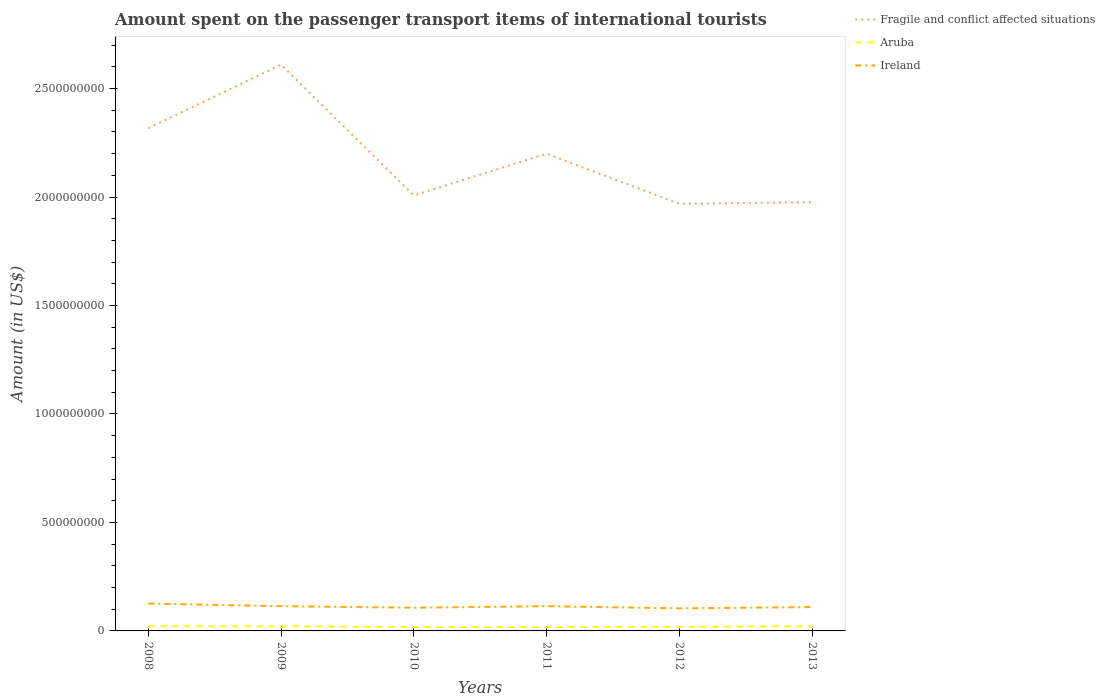How many different coloured lines are there?
Offer a very short reply. 3. Is the number of lines equal to the number of legend labels?
Offer a terse response. Yes. Across all years, what is the maximum amount spent on the passenger transport items of international tourists in Aruba?
Give a very brief answer. 1.80e+07. In which year was the amount spent on the passenger transport items of international tourists in Aruba maximum?
Keep it short and to the point. 2010. What is the total amount spent on the passenger transport items of international tourists in Ireland in the graph?
Provide a short and direct response. 1.90e+07. What is the difference between the highest and the second highest amount spent on the passenger transport items of international tourists in Aruba?
Offer a very short reply. 4.00e+06. Is the amount spent on the passenger transport items of international tourists in Fragile and conflict affected situations strictly greater than the amount spent on the passenger transport items of international tourists in Ireland over the years?
Give a very brief answer. No. How many lines are there?
Your answer should be compact. 3. How many years are there in the graph?
Ensure brevity in your answer.  6. What is the title of the graph?
Your response must be concise. Amount spent on the passenger transport items of international tourists. Does "Slovak Republic" appear as one of the legend labels in the graph?
Keep it short and to the point. No. What is the label or title of the Y-axis?
Offer a terse response. Amount (in US$). What is the Amount (in US$) in Fragile and conflict affected situations in 2008?
Provide a short and direct response. 2.32e+09. What is the Amount (in US$) of Aruba in 2008?
Offer a very short reply. 2.20e+07. What is the Amount (in US$) of Ireland in 2008?
Give a very brief answer. 1.26e+08. What is the Amount (in US$) in Fragile and conflict affected situations in 2009?
Make the answer very short. 2.61e+09. What is the Amount (in US$) in Aruba in 2009?
Keep it short and to the point. 2.10e+07. What is the Amount (in US$) in Ireland in 2009?
Your response must be concise. 1.14e+08. What is the Amount (in US$) in Fragile and conflict affected situations in 2010?
Ensure brevity in your answer.  2.01e+09. What is the Amount (in US$) of Aruba in 2010?
Your response must be concise. 1.80e+07. What is the Amount (in US$) in Ireland in 2010?
Offer a terse response. 1.07e+08. What is the Amount (in US$) of Fragile and conflict affected situations in 2011?
Your answer should be very brief. 2.20e+09. What is the Amount (in US$) in Aruba in 2011?
Provide a short and direct response. 1.80e+07. What is the Amount (in US$) of Ireland in 2011?
Provide a short and direct response. 1.14e+08. What is the Amount (in US$) in Fragile and conflict affected situations in 2012?
Offer a very short reply. 1.97e+09. What is the Amount (in US$) of Aruba in 2012?
Make the answer very short. 1.90e+07. What is the Amount (in US$) of Ireland in 2012?
Offer a terse response. 1.04e+08. What is the Amount (in US$) of Fragile and conflict affected situations in 2013?
Ensure brevity in your answer.  1.98e+09. What is the Amount (in US$) in Aruba in 2013?
Provide a short and direct response. 2.10e+07. What is the Amount (in US$) of Ireland in 2013?
Keep it short and to the point. 1.10e+08. Across all years, what is the maximum Amount (in US$) of Fragile and conflict affected situations?
Offer a very short reply. 2.61e+09. Across all years, what is the maximum Amount (in US$) of Aruba?
Ensure brevity in your answer.  2.20e+07. Across all years, what is the maximum Amount (in US$) of Ireland?
Offer a very short reply. 1.26e+08. Across all years, what is the minimum Amount (in US$) of Fragile and conflict affected situations?
Your answer should be compact. 1.97e+09. Across all years, what is the minimum Amount (in US$) of Aruba?
Provide a short and direct response. 1.80e+07. Across all years, what is the minimum Amount (in US$) of Ireland?
Make the answer very short. 1.04e+08. What is the total Amount (in US$) in Fragile and conflict affected situations in the graph?
Your response must be concise. 1.31e+1. What is the total Amount (in US$) of Aruba in the graph?
Give a very brief answer. 1.19e+08. What is the total Amount (in US$) of Ireland in the graph?
Provide a short and direct response. 6.75e+08. What is the difference between the Amount (in US$) of Fragile and conflict affected situations in 2008 and that in 2009?
Your answer should be compact. -2.92e+08. What is the difference between the Amount (in US$) in Aruba in 2008 and that in 2009?
Provide a succinct answer. 1.00e+06. What is the difference between the Amount (in US$) in Ireland in 2008 and that in 2009?
Offer a terse response. 1.20e+07. What is the difference between the Amount (in US$) in Fragile and conflict affected situations in 2008 and that in 2010?
Provide a short and direct response. 3.10e+08. What is the difference between the Amount (in US$) in Aruba in 2008 and that in 2010?
Provide a short and direct response. 4.00e+06. What is the difference between the Amount (in US$) in Ireland in 2008 and that in 2010?
Offer a terse response. 1.90e+07. What is the difference between the Amount (in US$) of Fragile and conflict affected situations in 2008 and that in 2011?
Ensure brevity in your answer.  1.18e+08. What is the difference between the Amount (in US$) of Aruba in 2008 and that in 2011?
Offer a very short reply. 4.00e+06. What is the difference between the Amount (in US$) of Fragile and conflict affected situations in 2008 and that in 2012?
Your answer should be very brief. 3.49e+08. What is the difference between the Amount (in US$) of Ireland in 2008 and that in 2012?
Offer a terse response. 2.20e+07. What is the difference between the Amount (in US$) of Fragile and conflict affected situations in 2008 and that in 2013?
Give a very brief answer. 3.41e+08. What is the difference between the Amount (in US$) in Aruba in 2008 and that in 2013?
Your response must be concise. 1.00e+06. What is the difference between the Amount (in US$) of Ireland in 2008 and that in 2013?
Offer a terse response. 1.60e+07. What is the difference between the Amount (in US$) of Fragile and conflict affected situations in 2009 and that in 2010?
Offer a very short reply. 6.03e+08. What is the difference between the Amount (in US$) in Ireland in 2009 and that in 2010?
Offer a terse response. 7.00e+06. What is the difference between the Amount (in US$) of Fragile and conflict affected situations in 2009 and that in 2011?
Ensure brevity in your answer.  4.10e+08. What is the difference between the Amount (in US$) in Aruba in 2009 and that in 2011?
Offer a terse response. 3.00e+06. What is the difference between the Amount (in US$) in Fragile and conflict affected situations in 2009 and that in 2012?
Your response must be concise. 6.41e+08. What is the difference between the Amount (in US$) of Fragile and conflict affected situations in 2009 and that in 2013?
Give a very brief answer. 6.34e+08. What is the difference between the Amount (in US$) of Fragile and conflict affected situations in 2010 and that in 2011?
Provide a short and direct response. -1.92e+08. What is the difference between the Amount (in US$) in Aruba in 2010 and that in 2011?
Your answer should be very brief. 0. What is the difference between the Amount (in US$) in Ireland in 2010 and that in 2011?
Give a very brief answer. -7.00e+06. What is the difference between the Amount (in US$) in Fragile and conflict affected situations in 2010 and that in 2012?
Give a very brief answer. 3.86e+07. What is the difference between the Amount (in US$) of Aruba in 2010 and that in 2012?
Provide a short and direct response. -1.00e+06. What is the difference between the Amount (in US$) in Ireland in 2010 and that in 2012?
Keep it short and to the point. 3.00e+06. What is the difference between the Amount (in US$) of Fragile and conflict affected situations in 2010 and that in 2013?
Your answer should be very brief. 3.11e+07. What is the difference between the Amount (in US$) in Fragile and conflict affected situations in 2011 and that in 2012?
Give a very brief answer. 2.31e+08. What is the difference between the Amount (in US$) of Ireland in 2011 and that in 2012?
Keep it short and to the point. 1.00e+07. What is the difference between the Amount (in US$) of Fragile and conflict affected situations in 2011 and that in 2013?
Offer a terse response. 2.23e+08. What is the difference between the Amount (in US$) of Fragile and conflict affected situations in 2012 and that in 2013?
Ensure brevity in your answer.  -7.56e+06. What is the difference between the Amount (in US$) of Ireland in 2012 and that in 2013?
Offer a terse response. -6.00e+06. What is the difference between the Amount (in US$) of Fragile and conflict affected situations in 2008 and the Amount (in US$) of Aruba in 2009?
Make the answer very short. 2.30e+09. What is the difference between the Amount (in US$) in Fragile and conflict affected situations in 2008 and the Amount (in US$) in Ireland in 2009?
Give a very brief answer. 2.20e+09. What is the difference between the Amount (in US$) in Aruba in 2008 and the Amount (in US$) in Ireland in 2009?
Offer a terse response. -9.20e+07. What is the difference between the Amount (in US$) of Fragile and conflict affected situations in 2008 and the Amount (in US$) of Aruba in 2010?
Offer a terse response. 2.30e+09. What is the difference between the Amount (in US$) of Fragile and conflict affected situations in 2008 and the Amount (in US$) of Ireland in 2010?
Make the answer very short. 2.21e+09. What is the difference between the Amount (in US$) of Aruba in 2008 and the Amount (in US$) of Ireland in 2010?
Make the answer very short. -8.50e+07. What is the difference between the Amount (in US$) in Fragile and conflict affected situations in 2008 and the Amount (in US$) in Aruba in 2011?
Your answer should be very brief. 2.30e+09. What is the difference between the Amount (in US$) of Fragile and conflict affected situations in 2008 and the Amount (in US$) of Ireland in 2011?
Your response must be concise. 2.20e+09. What is the difference between the Amount (in US$) of Aruba in 2008 and the Amount (in US$) of Ireland in 2011?
Provide a short and direct response. -9.20e+07. What is the difference between the Amount (in US$) in Fragile and conflict affected situations in 2008 and the Amount (in US$) in Aruba in 2012?
Make the answer very short. 2.30e+09. What is the difference between the Amount (in US$) of Fragile and conflict affected situations in 2008 and the Amount (in US$) of Ireland in 2012?
Make the answer very short. 2.21e+09. What is the difference between the Amount (in US$) in Aruba in 2008 and the Amount (in US$) in Ireland in 2012?
Your response must be concise. -8.20e+07. What is the difference between the Amount (in US$) of Fragile and conflict affected situations in 2008 and the Amount (in US$) of Aruba in 2013?
Make the answer very short. 2.30e+09. What is the difference between the Amount (in US$) in Fragile and conflict affected situations in 2008 and the Amount (in US$) in Ireland in 2013?
Ensure brevity in your answer.  2.21e+09. What is the difference between the Amount (in US$) in Aruba in 2008 and the Amount (in US$) in Ireland in 2013?
Make the answer very short. -8.80e+07. What is the difference between the Amount (in US$) in Fragile and conflict affected situations in 2009 and the Amount (in US$) in Aruba in 2010?
Give a very brief answer. 2.59e+09. What is the difference between the Amount (in US$) of Fragile and conflict affected situations in 2009 and the Amount (in US$) of Ireland in 2010?
Offer a terse response. 2.50e+09. What is the difference between the Amount (in US$) of Aruba in 2009 and the Amount (in US$) of Ireland in 2010?
Your answer should be compact. -8.60e+07. What is the difference between the Amount (in US$) in Fragile and conflict affected situations in 2009 and the Amount (in US$) in Aruba in 2011?
Give a very brief answer. 2.59e+09. What is the difference between the Amount (in US$) of Fragile and conflict affected situations in 2009 and the Amount (in US$) of Ireland in 2011?
Ensure brevity in your answer.  2.50e+09. What is the difference between the Amount (in US$) in Aruba in 2009 and the Amount (in US$) in Ireland in 2011?
Offer a very short reply. -9.30e+07. What is the difference between the Amount (in US$) of Fragile and conflict affected situations in 2009 and the Amount (in US$) of Aruba in 2012?
Your answer should be very brief. 2.59e+09. What is the difference between the Amount (in US$) of Fragile and conflict affected situations in 2009 and the Amount (in US$) of Ireland in 2012?
Make the answer very short. 2.51e+09. What is the difference between the Amount (in US$) of Aruba in 2009 and the Amount (in US$) of Ireland in 2012?
Offer a very short reply. -8.30e+07. What is the difference between the Amount (in US$) in Fragile and conflict affected situations in 2009 and the Amount (in US$) in Aruba in 2013?
Provide a succinct answer. 2.59e+09. What is the difference between the Amount (in US$) in Fragile and conflict affected situations in 2009 and the Amount (in US$) in Ireland in 2013?
Your answer should be very brief. 2.50e+09. What is the difference between the Amount (in US$) of Aruba in 2009 and the Amount (in US$) of Ireland in 2013?
Your response must be concise. -8.90e+07. What is the difference between the Amount (in US$) of Fragile and conflict affected situations in 2010 and the Amount (in US$) of Aruba in 2011?
Ensure brevity in your answer.  1.99e+09. What is the difference between the Amount (in US$) in Fragile and conflict affected situations in 2010 and the Amount (in US$) in Ireland in 2011?
Provide a short and direct response. 1.89e+09. What is the difference between the Amount (in US$) of Aruba in 2010 and the Amount (in US$) of Ireland in 2011?
Your response must be concise. -9.60e+07. What is the difference between the Amount (in US$) in Fragile and conflict affected situations in 2010 and the Amount (in US$) in Aruba in 2012?
Your answer should be compact. 1.99e+09. What is the difference between the Amount (in US$) of Fragile and conflict affected situations in 2010 and the Amount (in US$) of Ireland in 2012?
Make the answer very short. 1.90e+09. What is the difference between the Amount (in US$) in Aruba in 2010 and the Amount (in US$) in Ireland in 2012?
Your answer should be compact. -8.60e+07. What is the difference between the Amount (in US$) of Fragile and conflict affected situations in 2010 and the Amount (in US$) of Aruba in 2013?
Your response must be concise. 1.99e+09. What is the difference between the Amount (in US$) of Fragile and conflict affected situations in 2010 and the Amount (in US$) of Ireland in 2013?
Keep it short and to the point. 1.90e+09. What is the difference between the Amount (in US$) in Aruba in 2010 and the Amount (in US$) in Ireland in 2013?
Offer a very short reply. -9.20e+07. What is the difference between the Amount (in US$) in Fragile and conflict affected situations in 2011 and the Amount (in US$) in Aruba in 2012?
Provide a succinct answer. 2.18e+09. What is the difference between the Amount (in US$) of Fragile and conflict affected situations in 2011 and the Amount (in US$) of Ireland in 2012?
Your answer should be very brief. 2.10e+09. What is the difference between the Amount (in US$) of Aruba in 2011 and the Amount (in US$) of Ireland in 2012?
Offer a terse response. -8.60e+07. What is the difference between the Amount (in US$) of Fragile and conflict affected situations in 2011 and the Amount (in US$) of Aruba in 2013?
Ensure brevity in your answer.  2.18e+09. What is the difference between the Amount (in US$) of Fragile and conflict affected situations in 2011 and the Amount (in US$) of Ireland in 2013?
Ensure brevity in your answer.  2.09e+09. What is the difference between the Amount (in US$) in Aruba in 2011 and the Amount (in US$) in Ireland in 2013?
Keep it short and to the point. -9.20e+07. What is the difference between the Amount (in US$) of Fragile and conflict affected situations in 2012 and the Amount (in US$) of Aruba in 2013?
Make the answer very short. 1.95e+09. What is the difference between the Amount (in US$) of Fragile and conflict affected situations in 2012 and the Amount (in US$) of Ireland in 2013?
Your response must be concise. 1.86e+09. What is the difference between the Amount (in US$) of Aruba in 2012 and the Amount (in US$) of Ireland in 2013?
Offer a very short reply. -9.10e+07. What is the average Amount (in US$) of Fragile and conflict affected situations per year?
Keep it short and to the point. 2.18e+09. What is the average Amount (in US$) in Aruba per year?
Your answer should be compact. 1.98e+07. What is the average Amount (in US$) of Ireland per year?
Your response must be concise. 1.12e+08. In the year 2008, what is the difference between the Amount (in US$) of Fragile and conflict affected situations and Amount (in US$) of Aruba?
Keep it short and to the point. 2.30e+09. In the year 2008, what is the difference between the Amount (in US$) in Fragile and conflict affected situations and Amount (in US$) in Ireland?
Offer a terse response. 2.19e+09. In the year 2008, what is the difference between the Amount (in US$) of Aruba and Amount (in US$) of Ireland?
Your response must be concise. -1.04e+08. In the year 2009, what is the difference between the Amount (in US$) of Fragile and conflict affected situations and Amount (in US$) of Aruba?
Your answer should be compact. 2.59e+09. In the year 2009, what is the difference between the Amount (in US$) of Fragile and conflict affected situations and Amount (in US$) of Ireland?
Your answer should be very brief. 2.50e+09. In the year 2009, what is the difference between the Amount (in US$) in Aruba and Amount (in US$) in Ireland?
Make the answer very short. -9.30e+07. In the year 2010, what is the difference between the Amount (in US$) in Fragile and conflict affected situations and Amount (in US$) in Aruba?
Your response must be concise. 1.99e+09. In the year 2010, what is the difference between the Amount (in US$) in Fragile and conflict affected situations and Amount (in US$) in Ireland?
Give a very brief answer. 1.90e+09. In the year 2010, what is the difference between the Amount (in US$) of Aruba and Amount (in US$) of Ireland?
Provide a short and direct response. -8.90e+07. In the year 2011, what is the difference between the Amount (in US$) of Fragile and conflict affected situations and Amount (in US$) of Aruba?
Your answer should be compact. 2.18e+09. In the year 2011, what is the difference between the Amount (in US$) in Fragile and conflict affected situations and Amount (in US$) in Ireland?
Provide a succinct answer. 2.09e+09. In the year 2011, what is the difference between the Amount (in US$) of Aruba and Amount (in US$) of Ireland?
Make the answer very short. -9.60e+07. In the year 2012, what is the difference between the Amount (in US$) of Fragile and conflict affected situations and Amount (in US$) of Aruba?
Provide a short and direct response. 1.95e+09. In the year 2012, what is the difference between the Amount (in US$) in Fragile and conflict affected situations and Amount (in US$) in Ireland?
Keep it short and to the point. 1.86e+09. In the year 2012, what is the difference between the Amount (in US$) in Aruba and Amount (in US$) in Ireland?
Offer a terse response. -8.50e+07. In the year 2013, what is the difference between the Amount (in US$) in Fragile and conflict affected situations and Amount (in US$) in Aruba?
Ensure brevity in your answer.  1.96e+09. In the year 2013, what is the difference between the Amount (in US$) of Fragile and conflict affected situations and Amount (in US$) of Ireland?
Your answer should be very brief. 1.87e+09. In the year 2013, what is the difference between the Amount (in US$) in Aruba and Amount (in US$) in Ireland?
Offer a very short reply. -8.90e+07. What is the ratio of the Amount (in US$) of Fragile and conflict affected situations in 2008 to that in 2009?
Provide a short and direct response. 0.89. What is the ratio of the Amount (in US$) of Aruba in 2008 to that in 2009?
Offer a terse response. 1.05. What is the ratio of the Amount (in US$) in Ireland in 2008 to that in 2009?
Your response must be concise. 1.11. What is the ratio of the Amount (in US$) of Fragile and conflict affected situations in 2008 to that in 2010?
Give a very brief answer. 1.15. What is the ratio of the Amount (in US$) in Aruba in 2008 to that in 2010?
Give a very brief answer. 1.22. What is the ratio of the Amount (in US$) in Ireland in 2008 to that in 2010?
Ensure brevity in your answer.  1.18. What is the ratio of the Amount (in US$) in Fragile and conflict affected situations in 2008 to that in 2011?
Offer a terse response. 1.05. What is the ratio of the Amount (in US$) in Aruba in 2008 to that in 2011?
Keep it short and to the point. 1.22. What is the ratio of the Amount (in US$) of Ireland in 2008 to that in 2011?
Provide a short and direct response. 1.11. What is the ratio of the Amount (in US$) of Fragile and conflict affected situations in 2008 to that in 2012?
Keep it short and to the point. 1.18. What is the ratio of the Amount (in US$) of Aruba in 2008 to that in 2012?
Provide a succinct answer. 1.16. What is the ratio of the Amount (in US$) in Ireland in 2008 to that in 2012?
Keep it short and to the point. 1.21. What is the ratio of the Amount (in US$) in Fragile and conflict affected situations in 2008 to that in 2013?
Your answer should be very brief. 1.17. What is the ratio of the Amount (in US$) in Aruba in 2008 to that in 2013?
Your response must be concise. 1.05. What is the ratio of the Amount (in US$) in Ireland in 2008 to that in 2013?
Offer a terse response. 1.15. What is the ratio of the Amount (in US$) in Fragile and conflict affected situations in 2009 to that in 2010?
Give a very brief answer. 1.3. What is the ratio of the Amount (in US$) in Aruba in 2009 to that in 2010?
Your response must be concise. 1.17. What is the ratio of the Amount (in US$) in Ireland in 2009 to that in 2010?
Your answer should be compact. 1.07. What is the ratio of the Amount (in US$) of Fragile and conflict affected situations in 2009 to that in 2011?
Your answer should be very brief. 1.19. What is the ratio of the Amount (in US$) of Ireland in 2009 to that in 2011?
Provide a short and direct response. 1. What is the ratio of the Amount (in US$) of Fragile and conflict affected situations in 2009 to that in 2012?
Offer a terse response. 1.33. What is the ratio of the Amount (in US$) in Aruba in 2009 to that in 2012?
Offer a terse response. 1.11. What is the ratio of the Amount (in US$) in Ireland in 2009 to that in 2012?
Make the answer very short. 1.1. What is the ratio of the Amount (in US$) of Fragile and conflict affected situations in 2009 to that in 2013?
Offer a very short reply. 1.32. What is the ratio of the Amount (in US$) of Ireland in 2009 to that in 2013?
Your answer should be compact. 1.04. What is the ratio of the Amount (in US$) in Fragile and conflict affected situations in 2010 to that in 2011?
Make the answer very short. 0.91. What is the ratio of the Amount (in US$) in Aruba in 2010 to that in 2011?
Make the answer very short. 1. What is the ratio of the Amount (in US$) of Ireland in 2010 to that in 2011?
Offer a very short reply. 0.94. What is the ratio of the Amount (in US$) of Fragile and conflict affected situations in 2010 to that in 2012?
Provide a succinct answer. 1.02. What is the ratio of the Amount (in US$) of Ireland in 2010 to that in 2012?
Your answer should be compact. 1.03. What is the ratio of the Amount (in US$) of Fragile and conflict affected situations in 2010 to that in 2013?
Offer a very short reply. 1.02. What is the ratio of the Amount (in US$) in Aruba in 2010 to that in 2013?
Make the answer very short. 0.86. What is the ratio of the Amount (in US$) in Ireland in 2010 to that in 2013?
Give a very brief answer. 0.97. What is the ratio of the Amount (in US$) of Fragile and conflict affected situations in 2011 to that in 2012?
Your answer should be very brief. 1.12. What is the ratio of the Amount (in US$) of Ireland in 2011 to that in 2012?
Keep it short and to the point. 1.1. What is the ratio of the Amount (in US$) of Fragile and conflict affected situations in 2011 to that in 2013?
Make the answer very short. 1.11. What is the ratio of the Amount (in US$) of Ireland in 2011 to that in 2013?
Make the answer very short. 1.04. What is the ratio of the Amount (in US$) in Fragile and conflict affected situations in 2012 to that in 2013?
Make the answer very short. 1. What is the ratio of the Amount (in US$) in Aruba in 2012 to that in 2013?
Provide a short and direct response. 0.9. What is the ratio of the Amount (in US$) in Ireland in 2012 to that in 2013?
Provide a short and direct response. 0.95. What is the difference between the highest and the second highest Amount (in US$) in Fragile and conflict affected situations?
Give a very brief answer. 2.92e+08. What is the difference between the highest and the second highest Amount (in US$) of Aruba?
Give a very brief answer. 1.00e+06. What is the difference between the highest and the second highest Amount (in US$) in Ireland?
Offer a very short reply. 1.20e+07. What is the difference between the highest and the lowest Amount (in US$) in Fragile and conflict affected situations?
Your answer should be very brief. 6.41e+08. What is the difference between the highest and the lowest Amount (in US$) in Aruba?
Keep it short and to the point. 4.00e+06. What is the difference between the highest and the lowest Amount (in US$) in Ireland?
Ensure brevity in your answer.  2.20e+07. 